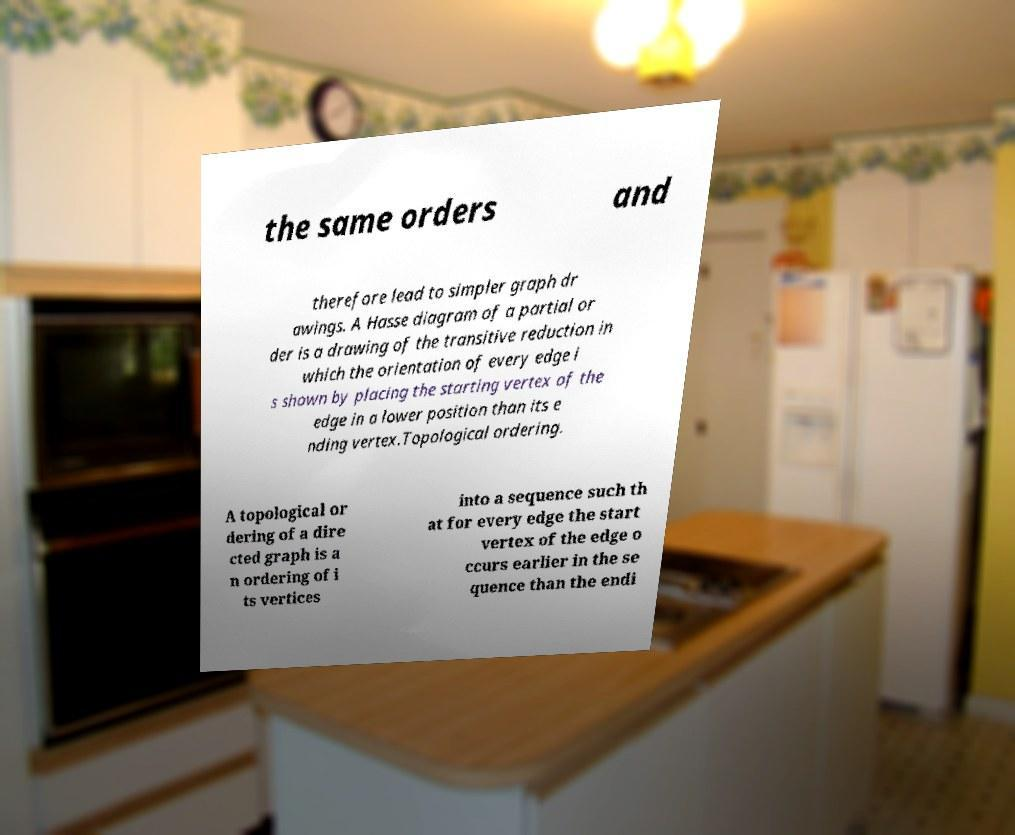I need the written content from this picture converted into text. Can you do that? the same orders and therefore lead to simpler graph dr awings. A Hasse diagram of a partial or der is a drawing of the transitive reduction in which the orientation of every edge i s shown by placing the starting vertex of the edge in a lower position than its e nding vertex.Topological ordering. A topological or dering of a dire cted graph is a n ordering of i ts vertices into a sequence such th at for every edge the start vertex of the edge o ccurs earlier in the se quence than the endi 